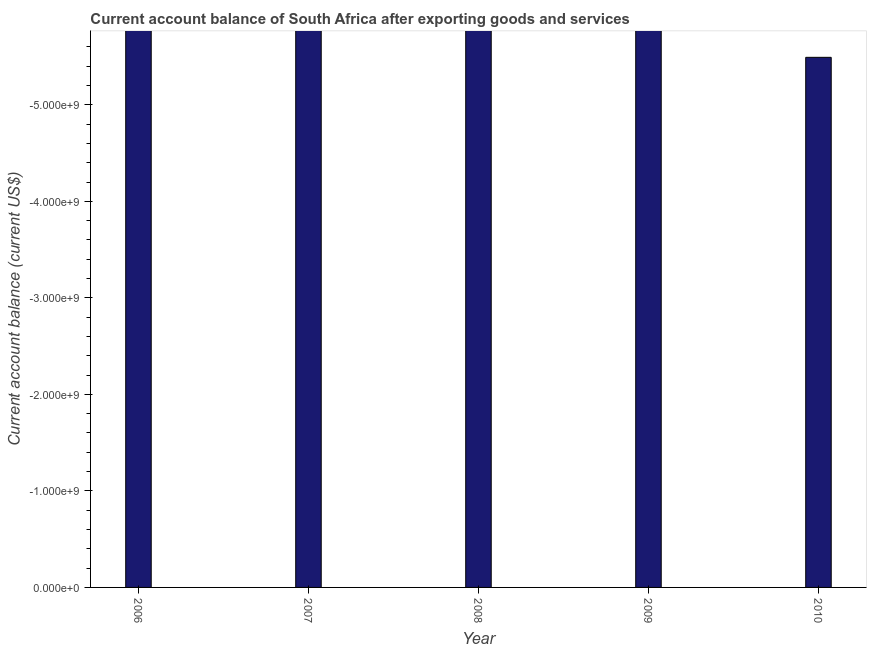Does the graph contain grids?
Give a very brief answer. No. What is the title of the graph?
Offer a very short reply. Current account balance of South Africa after exporting goods and services. What is the label or title of the Y-axis?
Your answer should be very brief. Current account balance (current US$). In how many years, is the current account balance greater than -1200000000 US$?
Offer a terse response. 0. How many bars are there?
Your response must be concise. 0. Are all the bars in the graph horizontal?
Provide a succinct answer. No. How many years are there in the graph?
Offer a terse response. 5. What is the Current account balance (current US$) in 2006?
Provide a succinct answer. 0. What is the Current account balance (current US$) of 2007?
Your response must be concise. 0. What is the Current account balance (current US$) in 2009?
Offer a very short reply. 0. What is the Current account balance (current US$) in 2010?
Your answer should be compact. 0. 